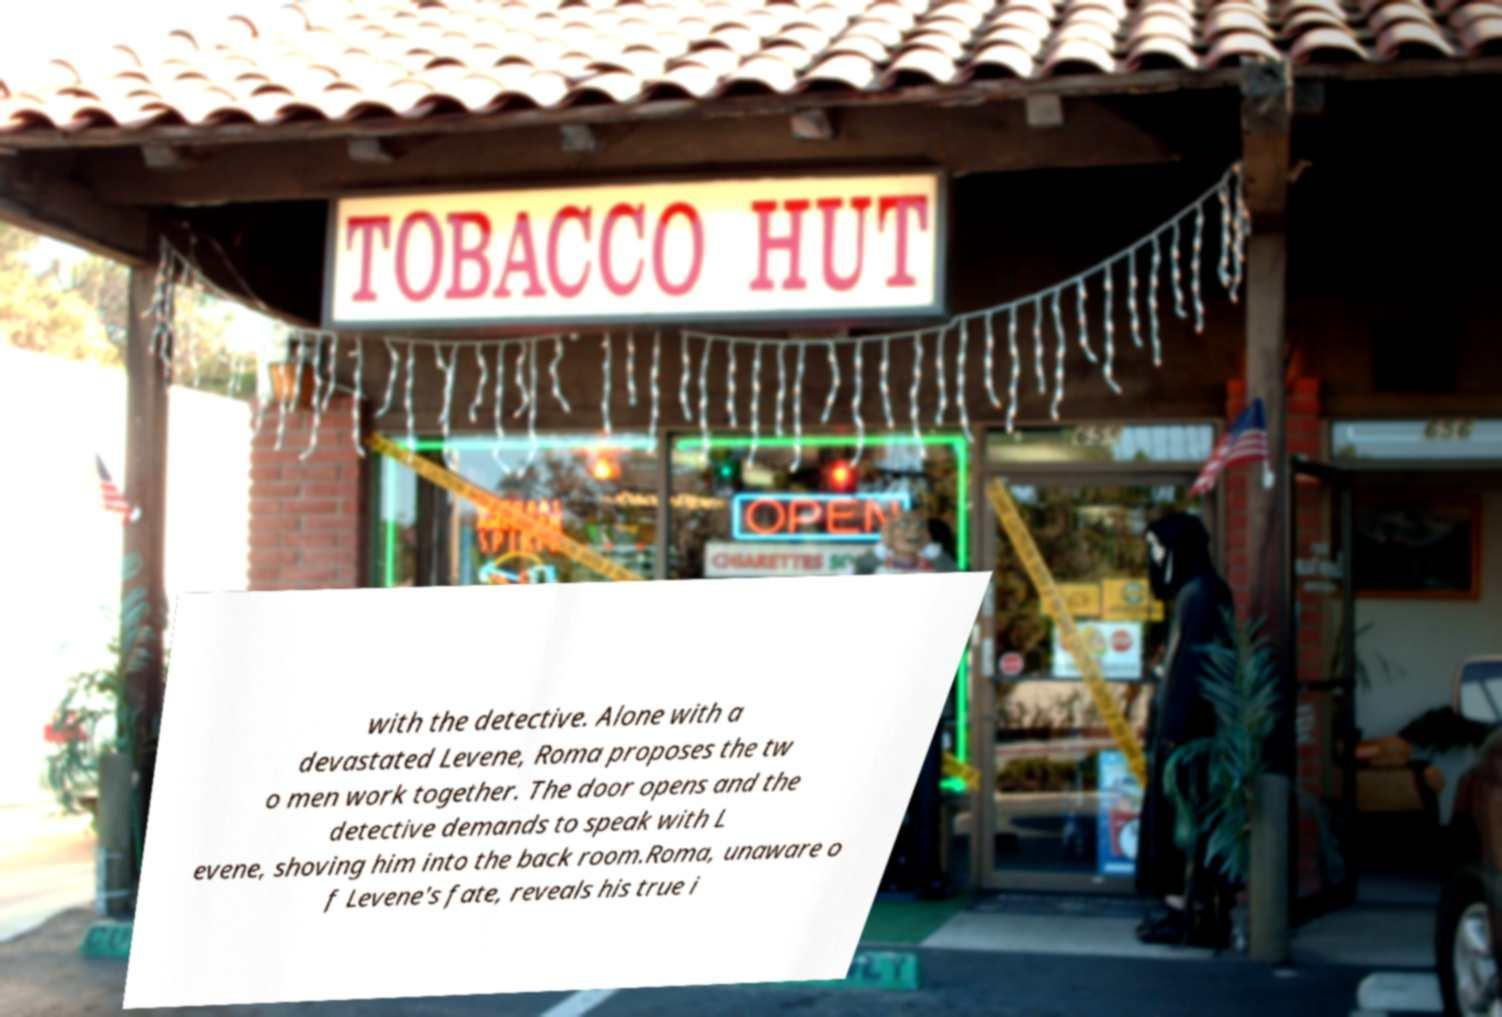Can you accurately transcribe the text from the provided image for me? with the detective. Alone with a devastated Levene, Roma proposes the tw o men work together. The door opens and the detective demands to speak with L evene, shoving him into the back room.Roma, unaware o f Levene's fate, reveals his true i 